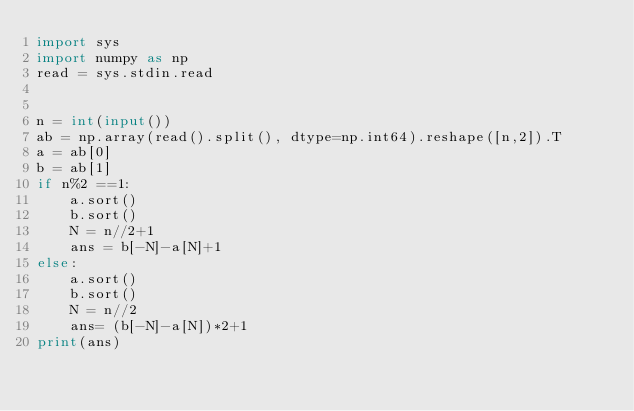<code> <loc_0><loc_0><loc_500><loc_500><_Python_>import sys
import numpy as np
read = sys.stdin.read


n = int(input())
ab = np.array(read().split(), dtype=np.int64).reshape([n,2]).T
a = ab[0]
b = ab[1]
if n%2 ==1:
    a.sort()
    b.sort()
    N = n//2+1
    ans = b[-N]-a[N]+1
else:
    a.sort()
    b.sort()
    N = n//2
    ans= (b[-N]-a[N])*2+1
print(ans)</code> 